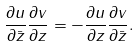Convert formula to latex. <formula><loc_0><loc_0><loc_500><loc_500>\frac { \partial u } { \partial \bar { z } } \frac { \partial v } { \partial z } = - \frac { \partial u } { \partial z } \frac { \partial v } { \partial \bar { z } } .</formula> 